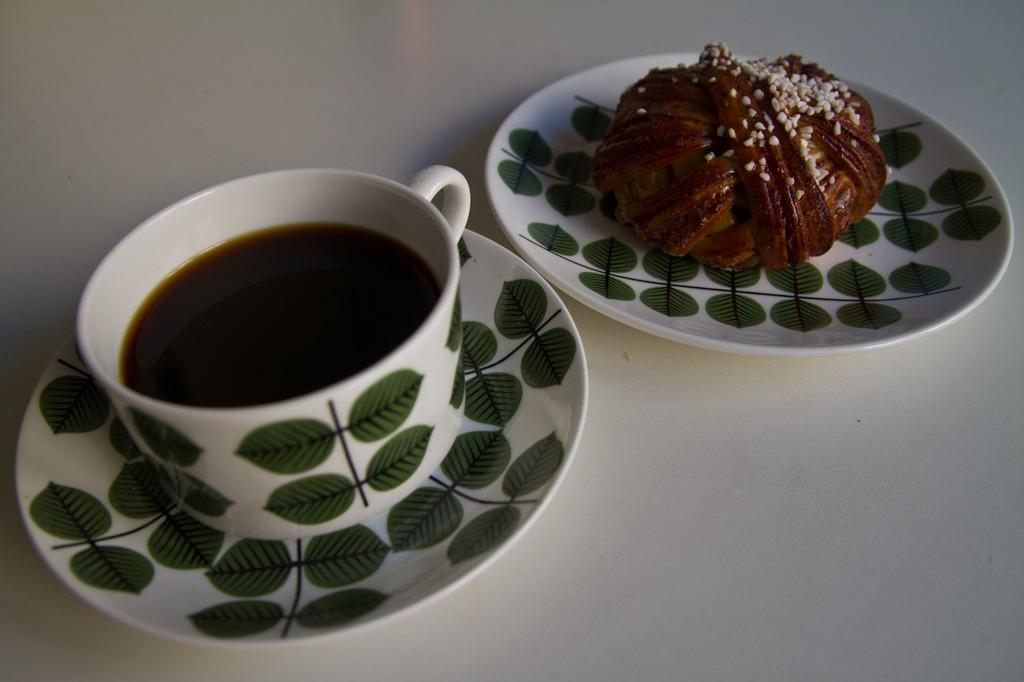What is present on the table in the image? There is a cup, a saucer, and a plate in the image. What is inside the cup? The cup contains a liquid. What is on the plate? The plate contains a food item. What is the color of the table in the image? The table is white in color. Can you see anyone committing a crime in the image? There is no indication of a crime or any people in the image. How does the plate smile in the image? The plate does not have the ability to smile, as it is an inanimate object. 